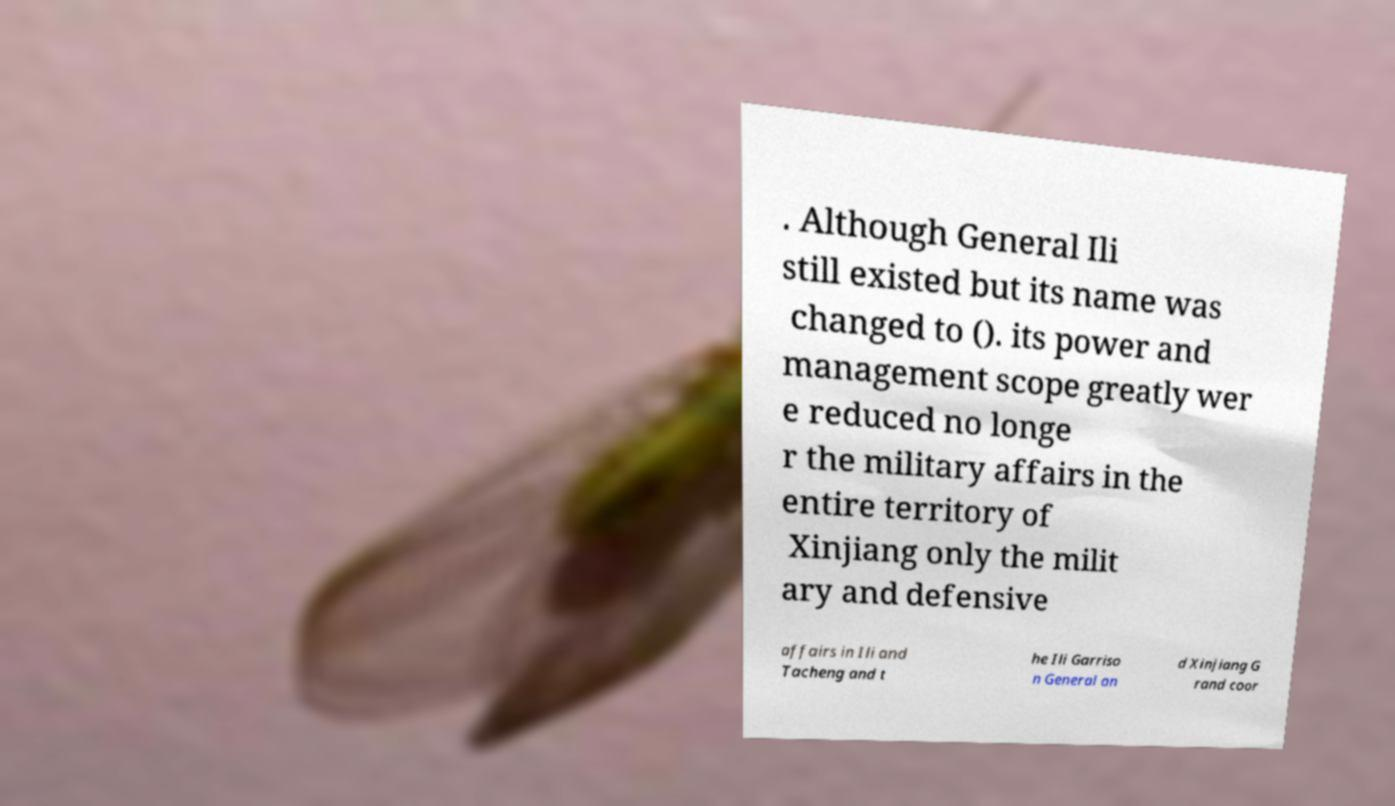Can you accurately transcribe the text from the provided image for me? . Although General Ili still existed but its name was changed to (). its power and management scope greatly wer e reduced no longe r the military affairs in the entire territory of Xinjiang only the milit ary and defensive affairs in Ili and Tacheng and t he Ili Garriso n General an d Xinjiang G rand coor 